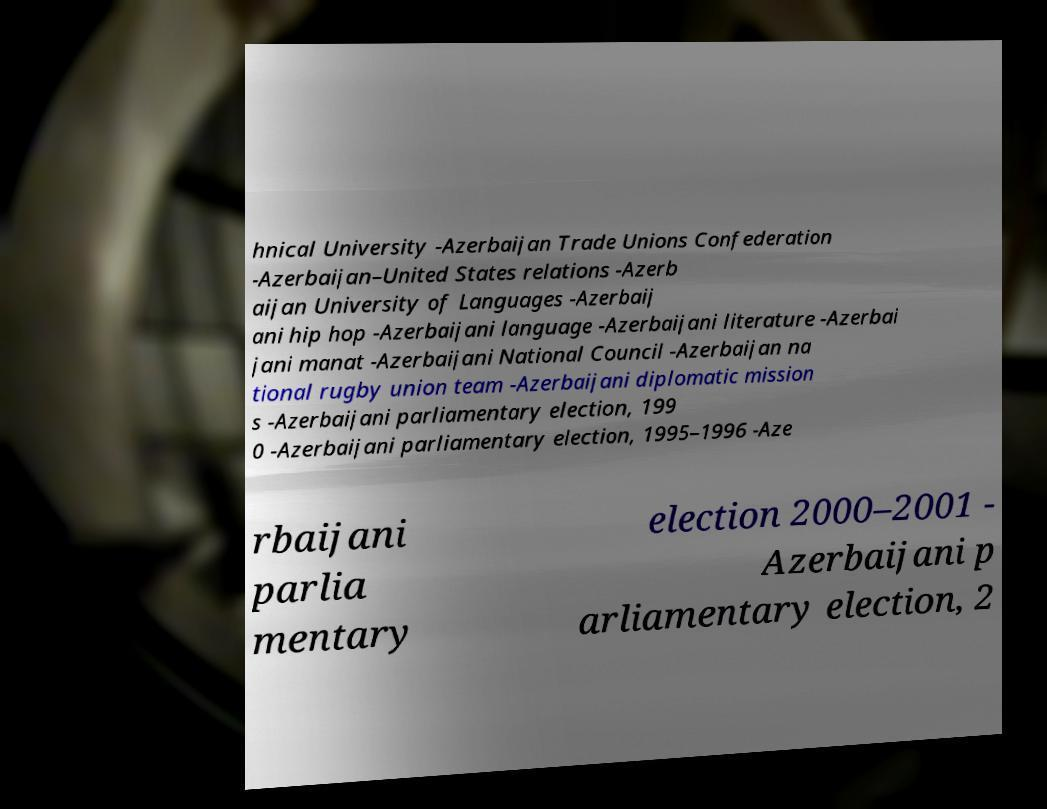What messages or text are displayed in this image? I need them in a readable, typed format. hnical University -Azerbaijan Trade Unions Confederation -Azerbaijan–United States relations -Azerb aijan University of Languages -Azerbaij ani hip hop -Azerbaijani language -Azerbaijani literature -Azerbai jani manat -Azerbaijani National Council -Azerbaijan na tional rugby union team -Azerbaijani diplomatic mission s -Azerbaijani parliamentary election, 199 0 -Azerbaijani parliamentary election, 1995–1996 -Aze rbaijani parlia mentary election 2000–2001 - Azerbaijani p arliamentary election, 2 